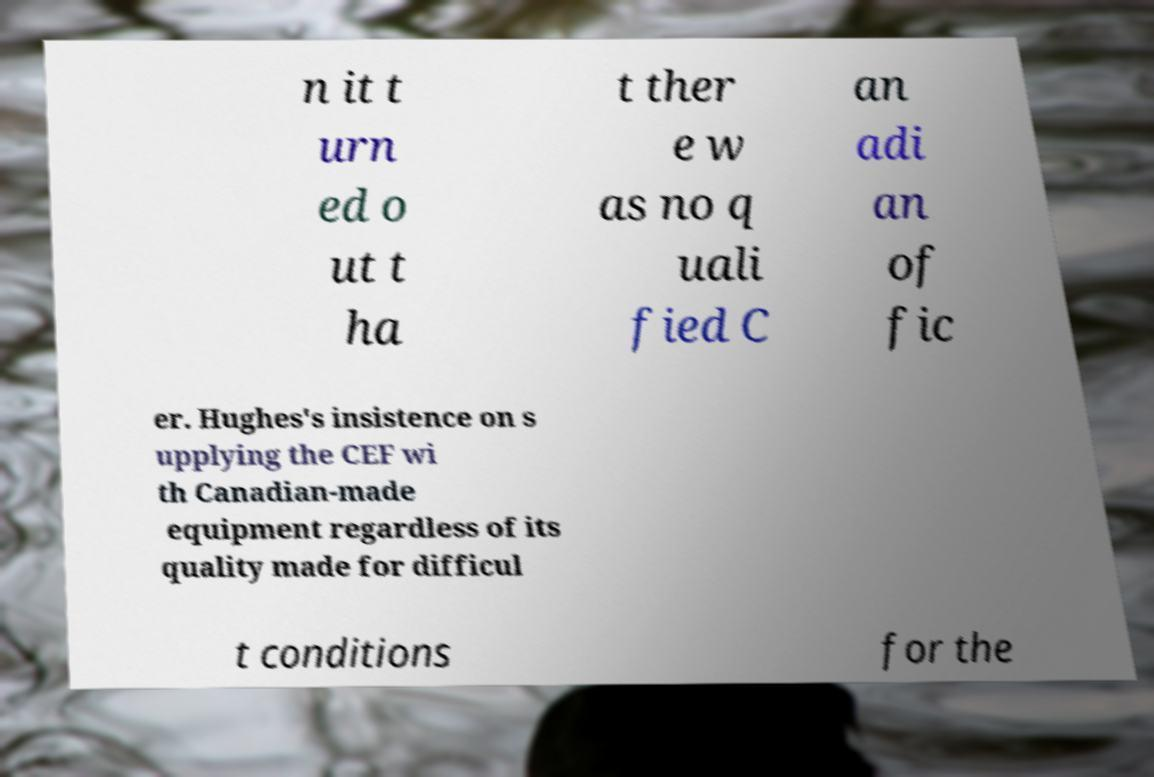There's text embedded in this image that I need extracted. Can you transcribe it verbatim? n it t urn ed o ut t ha t ther e w as no q uali fied C an adi an of fic er. Hughes's insistence on s upplying the CEF wi th Canadian-made equipment regardless of its quality made for difficul t conditions for the 